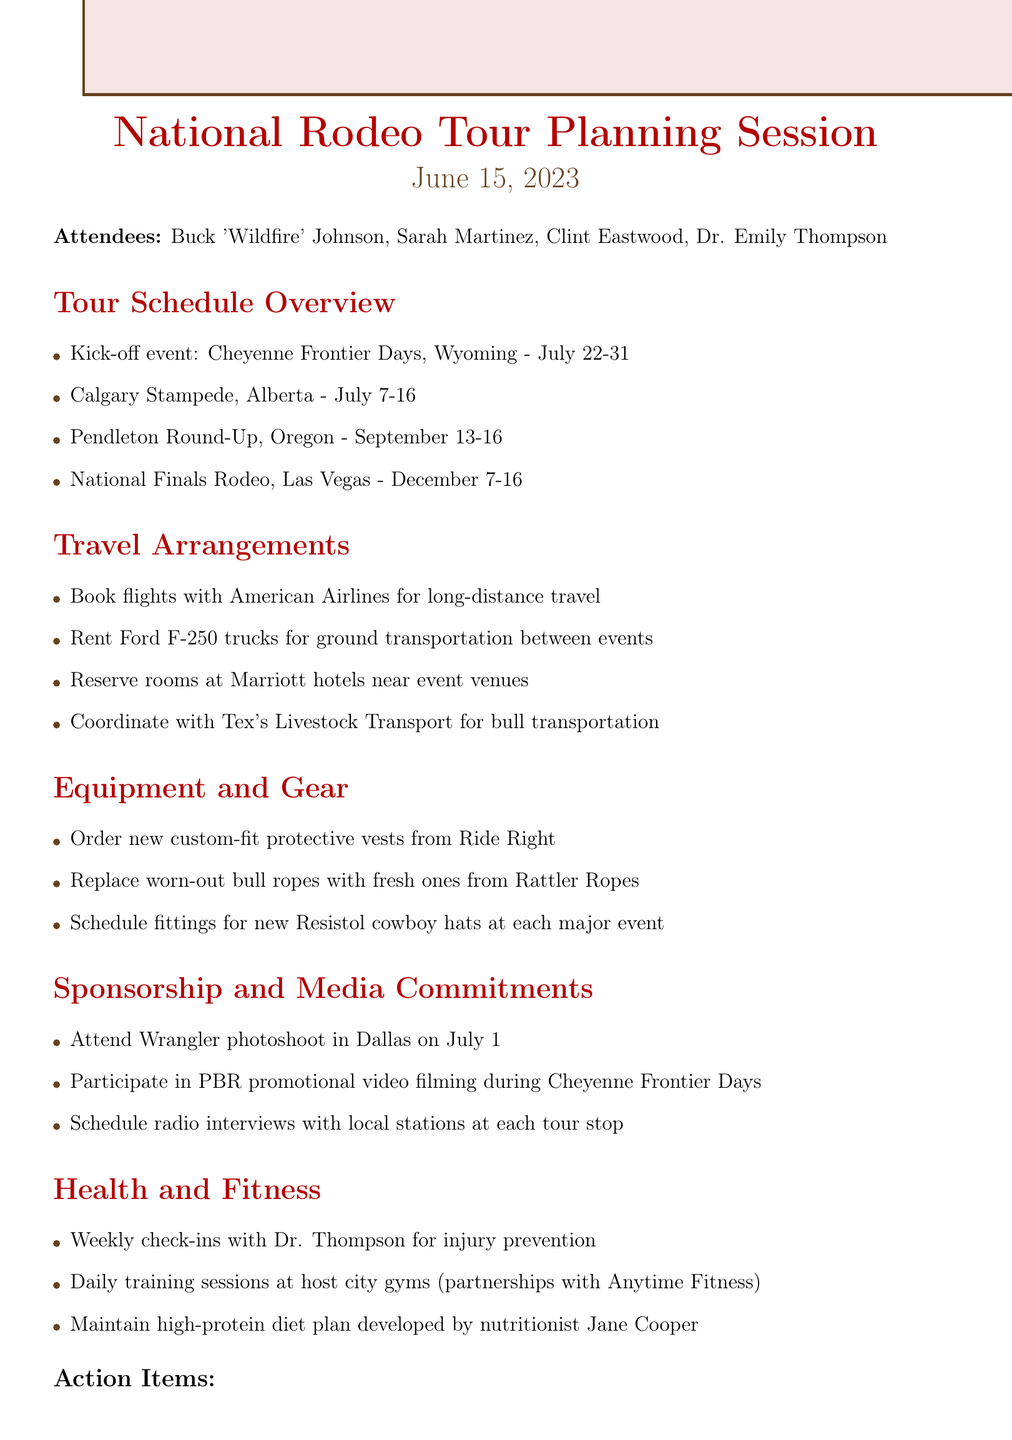what is the date of the meeting? The date of the meeting is stated as June 15, 2023.
Answer: June 15, 2023 who is the lead rider? The lead rider is identified in the attendees as Buck 'Wildfire' Johnson.
Answer: Buck 'Wildfire' Johnson what is the kick-off event? The kick-off event is specified in the document as Cheyenne Frontier Days, Wyoming.
Answer: Cheyenne Frontier Days, Wyoming when is the Calgary Stampede? The dates for the Calgary Stampede are provided in the tour schedule section as July 7-16.
Answer: July 7-16 which airline is mentioned for long-distance travel? The document states that American Airlines is to be used for long-distance travel arrangements.
Answer: American Airlines how many events are scheduled before the National Finals Rodeo? There are three events listed before the National Finals Rodeo in the schedule section.
Answer: Three who is responsible for finalizing hotel bookings? Sarah Martinez is designated to finalize hotel bookings and transportation reservations.
Answer: Sarah what health-related plan is mentioned for Buck? The Action Items section states that Dr. Thompson is to create a personalized fitness plan for Buck.
Answer: Personalized fitness plan 